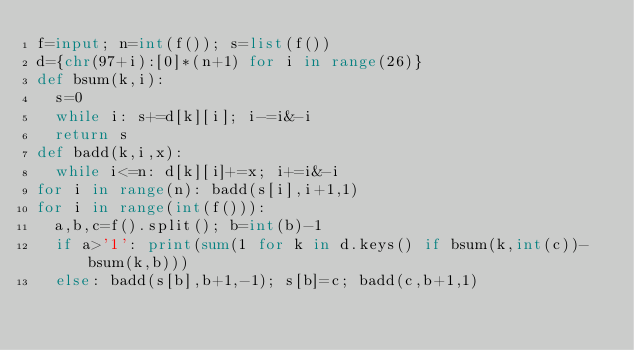<code> <loc_0><loc_0><loc_500><loc_500><_Python_>f=input; n=int(f()); s=list(f())
d={chr(97+i):[0]*(n+1) for i in range(26)}
def bsum(k,i):
  s=0
  while i: s+=d[k][i]; i-=i&-i
  return s
def badd(k,i,x):
  while i<=n: d[k][i]+=x; i+=i&-i
for i in range(n): badd(s[i],i+1,1)
for i in range(int(f())):
  a,b,c=f().split(); b=int(b)-1
  if a>'1': print(sum(1 for k in d.keys() if bsum(k,int(c))-bsum(k,b)))
  else: badd(s[b],b+1,-1); s[b]=c; badd(c,b+1,1)</code> 